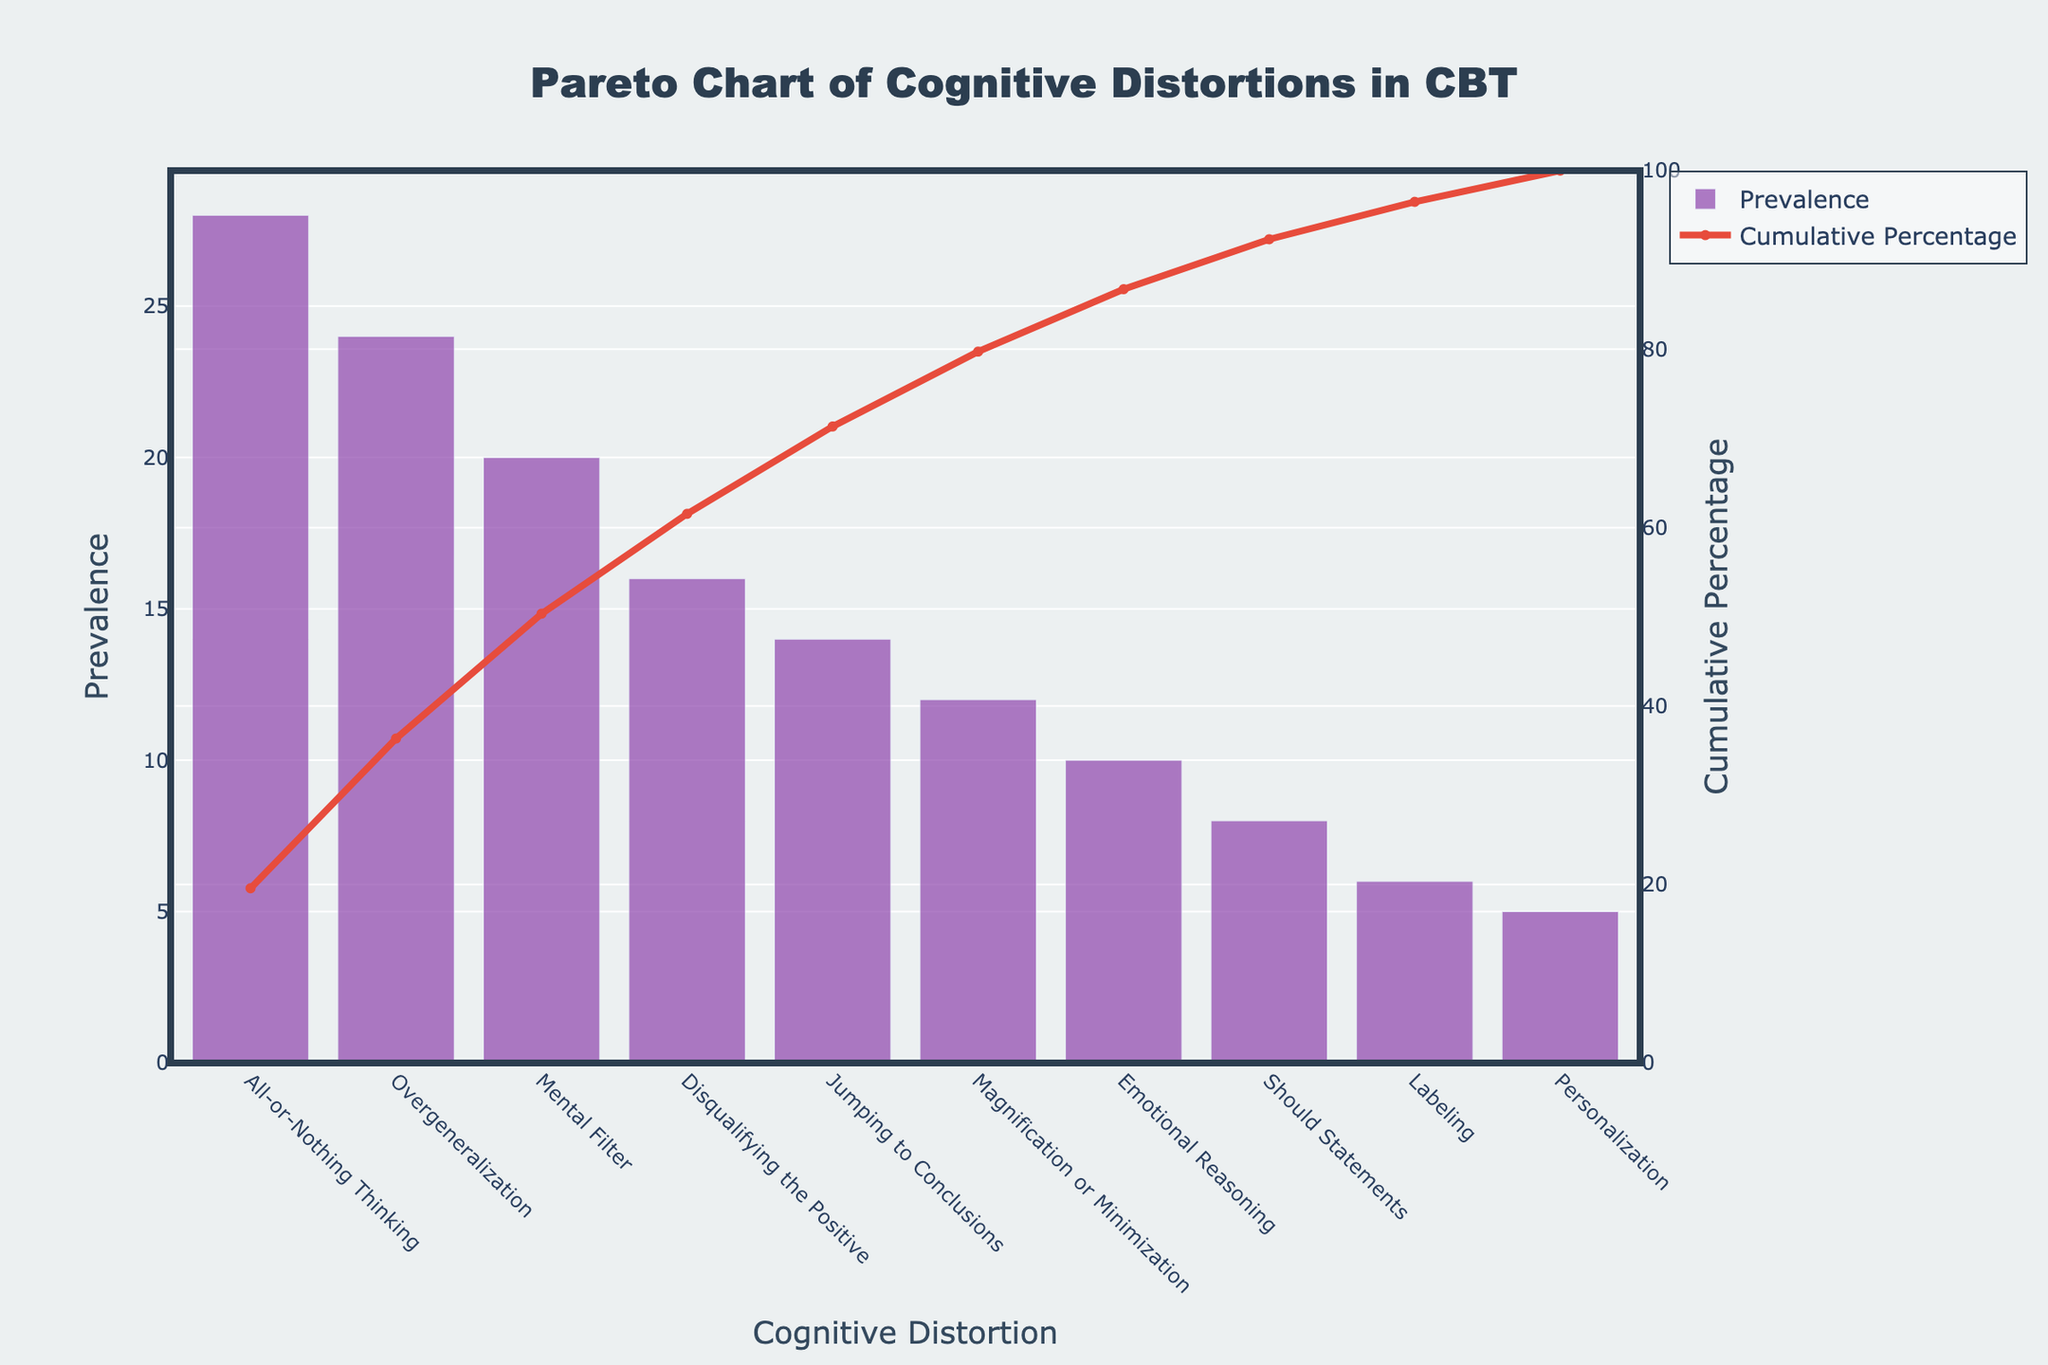What's the title of the chart? The title is displayed at the top center of the chart area. It provides a concise description of the data being visualized.
Answer: Pareto Chart of Cognitive Distortions in CBT What does the y-axis on the left represent? The y-axis on the left shows the prevalence of each cognitive distortion, indicating how common each type is.
Answer: Prevalence What color are the bars representing prevalence? The color of the bars can be seen in the chart where each bar representing prevalence is colored.
Answer: Purple How many cognitive distortions have a prevalence greater than 20? To answer this, check the bars where the prevalence axis shows values greater than 20. Count the number of such bars. There are three: All-or-Nothing Thinking (28), Overgeneralization (24), and Mental Filter (20).
Answer: 3 Which cognitive distortions make up approximately 65% of the cumulative prevalence? The cumulative percentage line indicates how much of the overall total each distortion contributes. By looking at the cumulative percentage line, we identify the points where the line crosses approximately 65%. The cognitive distortions are: All-or-Nothing Thinking, Overgeneralization, and Mental Filter.
Answer: All-or-Nothing Thinking, Overgeneralization, Mental Filter What is the cumulative percentage for 'Jumping to Conclusions'? To find this, locate the point on the cumulative percentage line that corresponds to 'Jumping to Conclusions'.
Answer: 76% Which cognitive distortion has the highest prevalence? The bar with the greatest height indicates the cognitive distortion with the highest prevalence.
Answer: All-or-Nothing Thinking How many cognitive distortions are represented in the chart? Count the number of bars in the chart, as each bar represents one cognitive distortion.
Answer: 10 What is the prevalence of 'Labeling' compared to 'Disqualifying the Positive'? To compare, find the heights of the bars for 'Labeling' and 'Disqualifying the Positive' and check their values. 'Labeling' has a prevalence of 6, and 'Disqualifying the Positive' has a prevalence of 16. 6 compared to 16 shows that 'Disqualifying the Positive' is higher.
Answer: Disqualifying the Positive is higher What is the prevalence value of the least common cognitive distortion? Identify the shortest bar on the chart, which represents the least common cognitive distortion, and read its prevalence value.
Answer: 5 